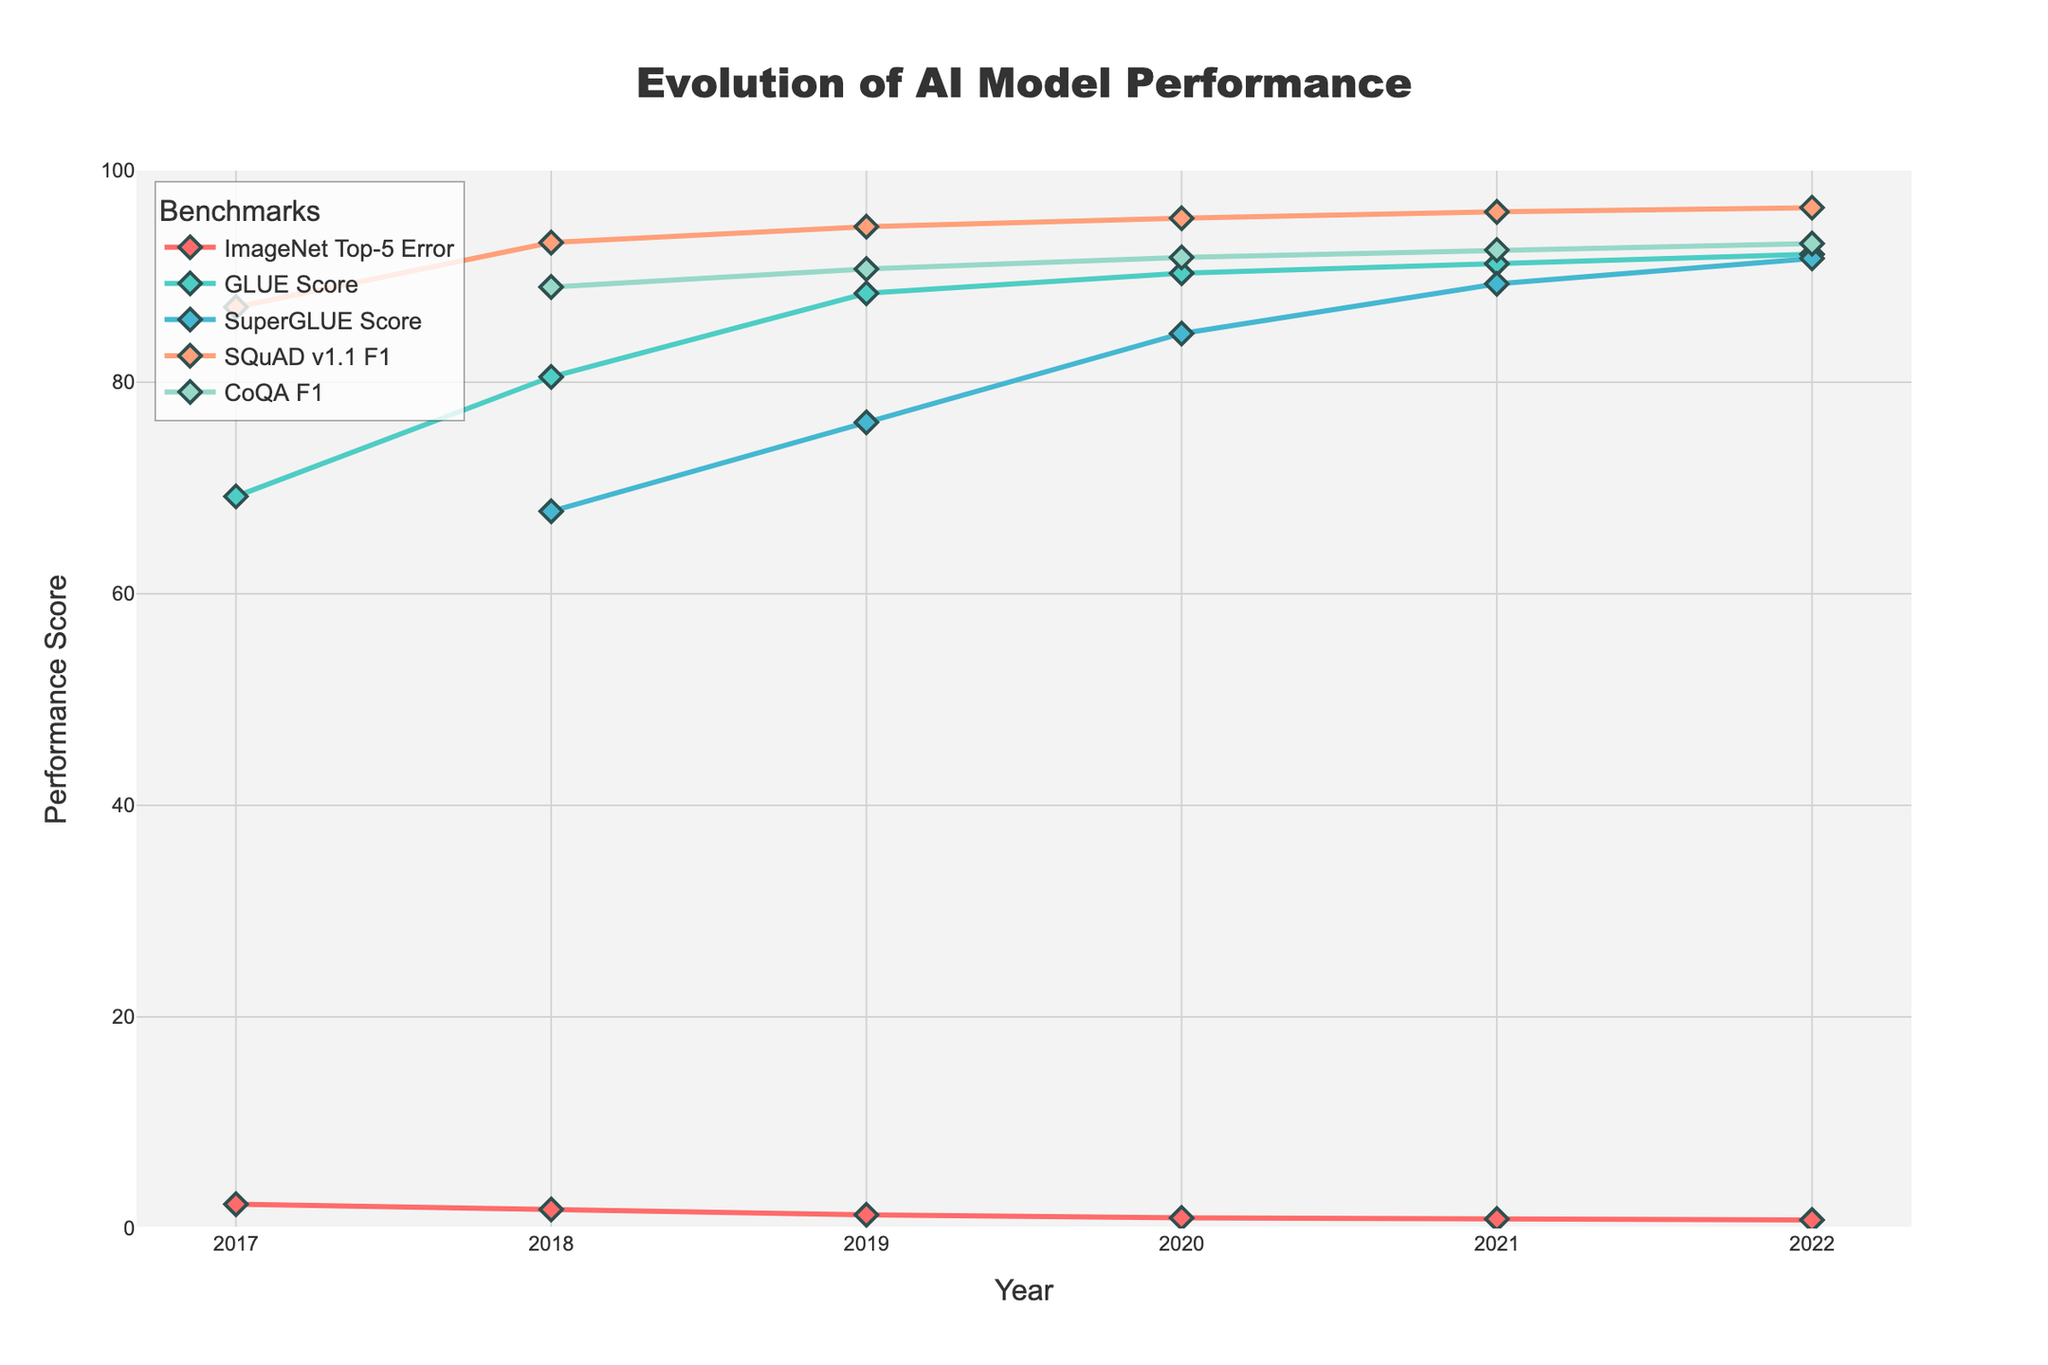What is the trend of the ImageNet Top-5 Error over the years? The ImageNet Top-5 Error has consistently decreased from 2017 to 2022 according to the line trend, indicating improving performance on the benchmark.
Answer: Decreasing Which benchmark achieved the highest performance score in 2022? In 2022, the highest performance score among all benchmarks was achieved by SQuAD v1.1 F1, as its line is the highest on the vertical axis.
Answer: SQuAD v1.1 F1 What is the difference in GLUE Score from 2018 to 2022? The GLUE Score in 2018 is 80.5, and in 2022 it is 92.1. The difference is calculated as 92.1 - 80.5 = 11.6.
Answer: 11.6 How does the evolution of SuperGLUE Score compare to CoQA F1 Score between 2019 and 2022? Both metrics show an increasing trend. SuperGLUE Score improved from 76.2 in 2019 to 91.7 in 2022, while CoQA F1 increased from 90.7 in 2019 to 93.1 in 2022. CoQA had a smaller increase compared to SuperGLUE.
Answer: SuperGLUE improved more What is the average performance score of the SQuAD v1.1 F1 benchmark from 2018 to 2022? The SQuAD v1.1 F1 scores are 93.2 (2018), 94.7 (2019), 95.5 (2020), 96.1 (2021), and 96.5 (2022). The average is calculated as (93.2 + 94.7 + 95.5 + 96.1 + 96.5) / 5 = 95.2.
Answer: 95.2 Which year had the greatest increase in GLUE Score compared to the previous year? The GLUE Score increased by the following amounts compared to the previous year: 11.3 (2017 to 2018), 7.9 (2018 to 2019), 1.9 (2019 to 2020), 0.9 (2020 to 2021), 0.9 (2021 to 2022). The greatest increase is from 2017 to 2018.
Answer: 2018 Identify the color of the line representing the GLUE Score. The color of the line for the GLUE Score is identified as a light teal or cyan based on the visual inspection.
Answer: Teal/Cyan From 2019 to 2022, which metric shows the smallest rate of improvement? SuperGLUE Score increased from 76.2 to 91.7, GLUE Score from 88.4 to 92.1, ImageNet Top-5 Error from 1.3 to 0.8, CoQA F1 from 90.7 to 93.1, and SQuAD v1.1 F1 from 94.7 to 96.5. The smallest improvement percentage-wise is in CoQA F1.
Answer: CoQA F1 Compare the ImageNet Top-5 Error in 2021 to its value in 2020. Did it improve or worsen? The ImageNet Top-5 Error improved, as it decreased from 1.0 in 2020 to 0.9 in 2021.
Answer: Improved 